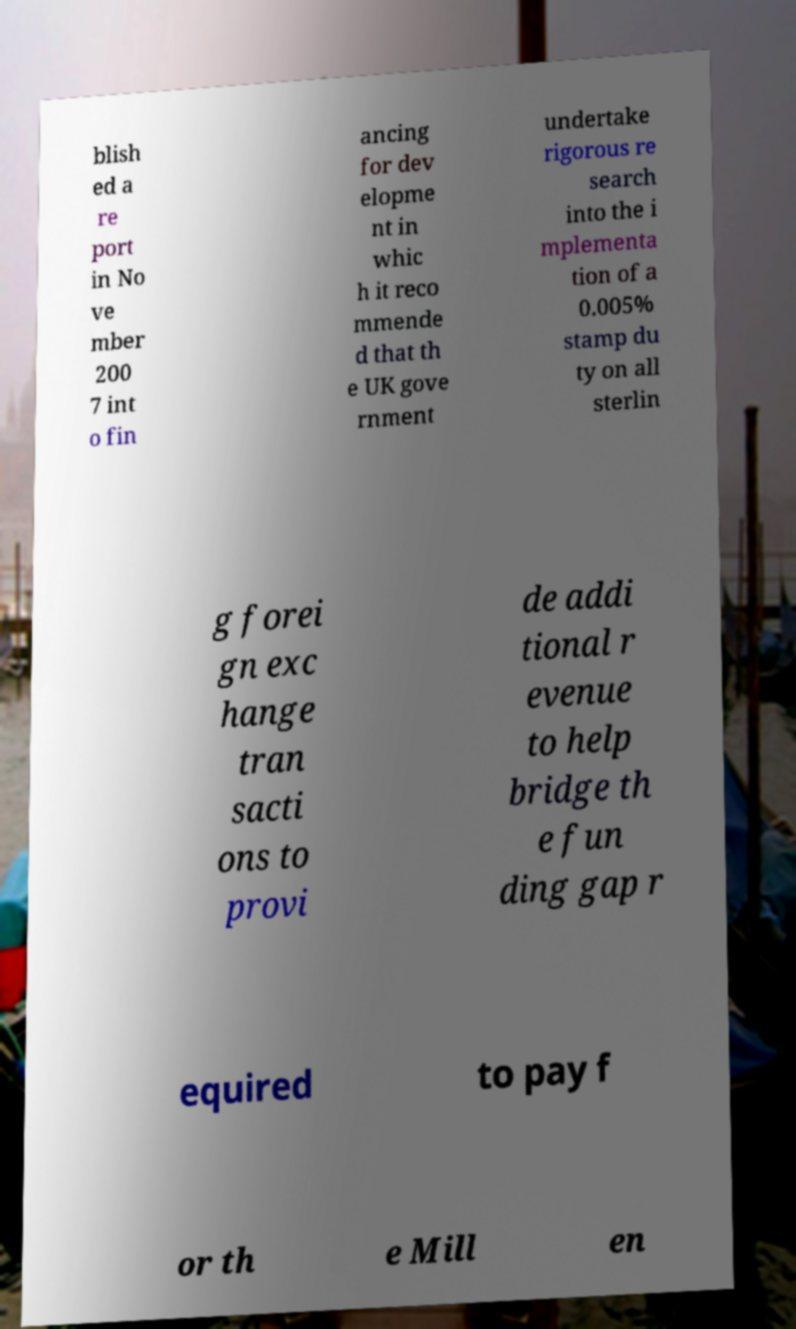Please identify and transcribe the text found in this image. blish ed a re port in No ve mber 200 7 int o fin ancing for dev elopme nt in whic h it reco mmende d that th e UK gove rnment undertake rigorous re search into the i mplementa tion of a 0.005% stamp du ty on all sterlin g forei gn exc hange tran sacti ons to provi de addi tional r evenue to help bridge th e fun ding gap r equired to pay f or th e Mill en 